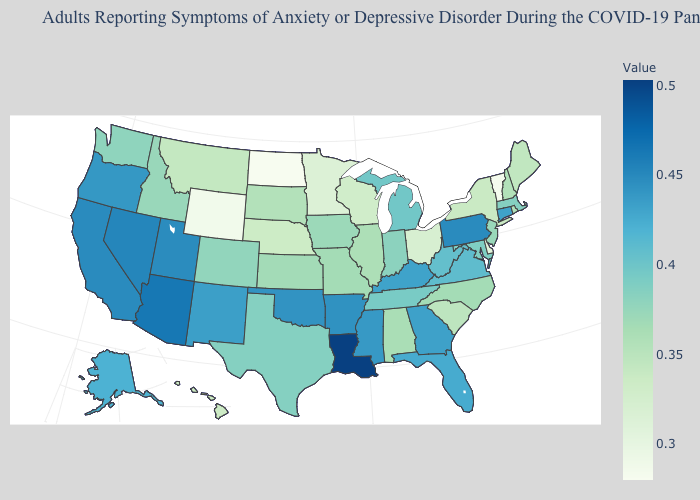Which states have the lowest value in the West?
Write a very short answer. Wyoming. Does Louisiana have the highest value in the South?
Concise answer only. Yes. Among the states that border Wyoming , does Utah have the lowest value?
Short answer required. No. Which states have the lowest value in the West?
Short answer required. Wyoming. 